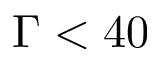<formula> <loc_0><loc_0><loc_500><loc_500>\Gamma < 4 0</formula> 